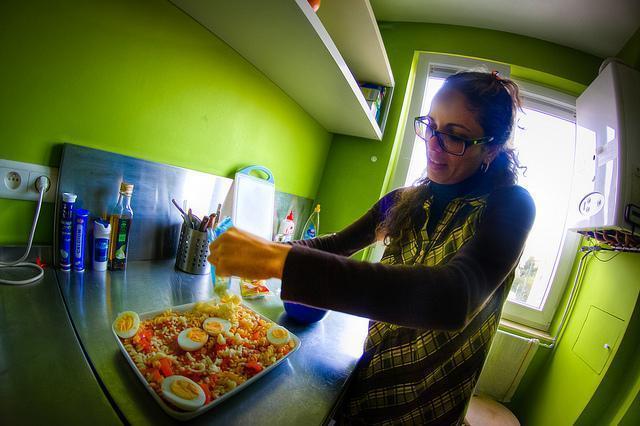How many sinks are to the right of the shower?
Give a very brief answer. 0. 